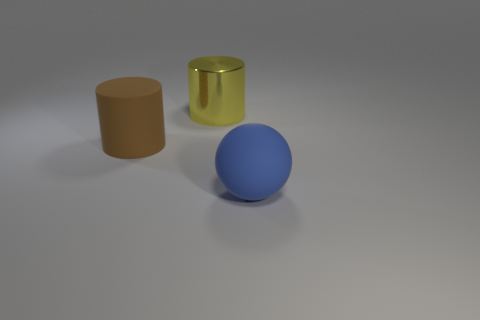Subtract 1 cylinders. How many cylinders are left? 1 Add 2 big cyan rubber blocks. How many objects exist? 5 Subtract all cylinders. How many objects are left? 1 Add 2 yellow shiny cylinders. How many yellow shiny cylinders are left? 3 Add 1 blue things. How many blue things exist? 2 Subtract 0 green spheres. How many objects are left? 3 Subtract all purple blocks. Subtract all brown matte cylinders. How many objects are left? 2 